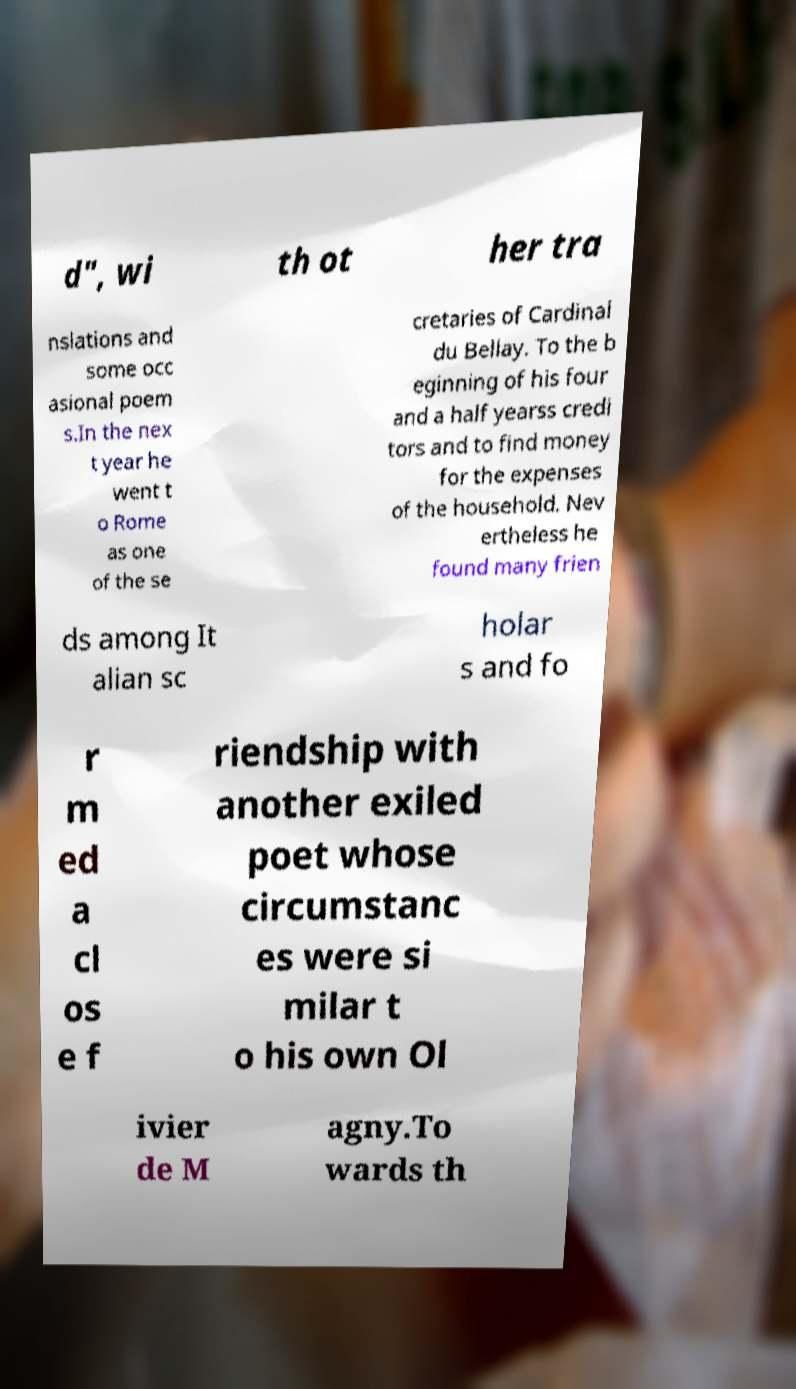Can you accurately transcribe the text from the provided image for me? d", wi th ot her tra nslations and some occ asional poem s.In the nex t year he went t o Rome as one of the se cretaries of Cardinal du Bellay. To the b eginning of his four and a half yearss credi tors and to find money for the expenses of the household. Nev ertheless he found many frien ds among It alian sc holar s and fo r m ed a cl os e f riendship with another exiled poet whose circumstanc es were si milar t o his own Ol ivier de M agny.To wards th 